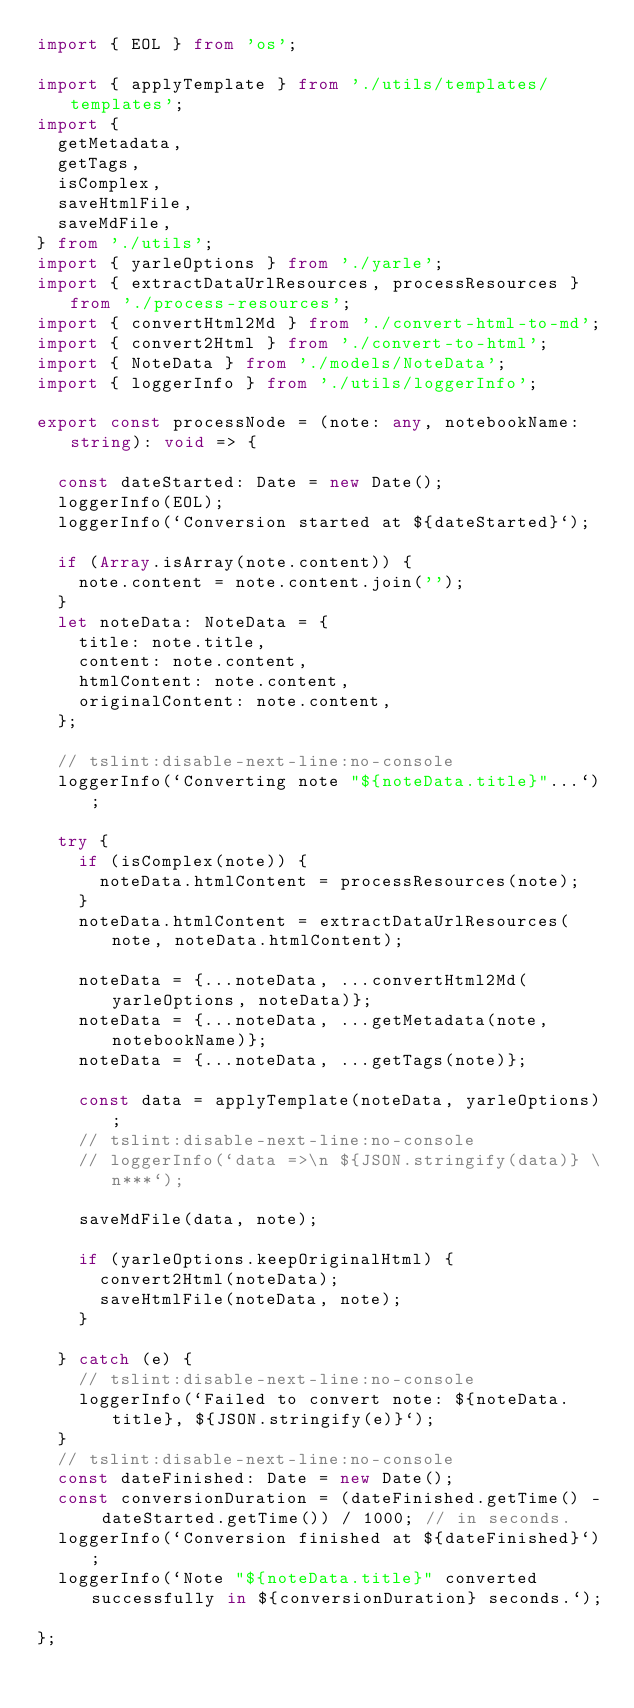<code> <loc_0><loc_0><loc_500><loc_500><_TypeScript_>import { EOL } from 'os';

import { applyTemplate } from './utils/templates/templates';
import {
  getMetadata,
  getTags,
  isComplex,
  saveHtmlFile,
  saveMdFile,
} from './utils';
import { yarleOptions } from './yarle';
import { extractDataUrlResources, processResources } from './process-resources';
import { convertHtml2Md } from './convert-html-to-md';
import { convert2Html } from './convert-to-html';
import { NoteData } from './models/NoteData';
import { loggerInfo } from './utils/loggerInfo';

export const processNode = (note: any, notebookName: string): void => {

  const dateStarted: Date = new Date();
  loggerInfo(EOL);
  loggerInfo(`Conversion started at ${dateStarted}`);

  if (Array.isArray(note.content)) {
    note.content = note.content.join('');
  }
  let noteData: NoteData = {
    title: note.title,
    content: note.content,
    htmlContent: note.content,
    originalContent: note.content,
  };

  // tslint:disable-next-line:no-console
  loggerInfo(`Converting note "${noteData.title}"...`);

  try {
    if (isComplex(note)) {
      noteData.htmlContent = processResources(note);
    }
    noteData.htmlContent = extractDataUrlResources(note, noteData.htmlContent);

    noteData = {...noteData, ...convertHtml2Md(yarleOptions, noteData)};
    noteData = {...noteData, ...getMetadata(note, notebookName)};
    noteData = {...noteData, ...getTags(note)};

    const data = applyTemplate(noteData, yarleOptions);
    // tslint:disable-next-line:no-console
    // loggerInfo(`data =>\n ${JSON.stringify(data)} \n***`);

    saveMdFile(data, note);

    if (yarleOptions.keepOriginalHtml) {
      convert2Html(noteData);
      saveHtmlFile(noteData, note);
    }

  } catch (e) {
    // tslint:disable-next-line:no-console
    loggerInfo(`Failed to convert note: ${noteData.title}, ${JSON.stringify(e)}`);
  }
  // tslint:disable-next-line:no-console
  const dateFinished: Date = new Date();
  const conversionDuration = (dateFinished.getTime() - dateStarted.getTime()) / 1000; // in seconds.
  loggerInfo(`Conversion finished at ${dateFinished}`);
  loggerInfo(`Note "${noteData.title}" converted successfully in ${conversionDuration} seconds.`);

};
</code> 